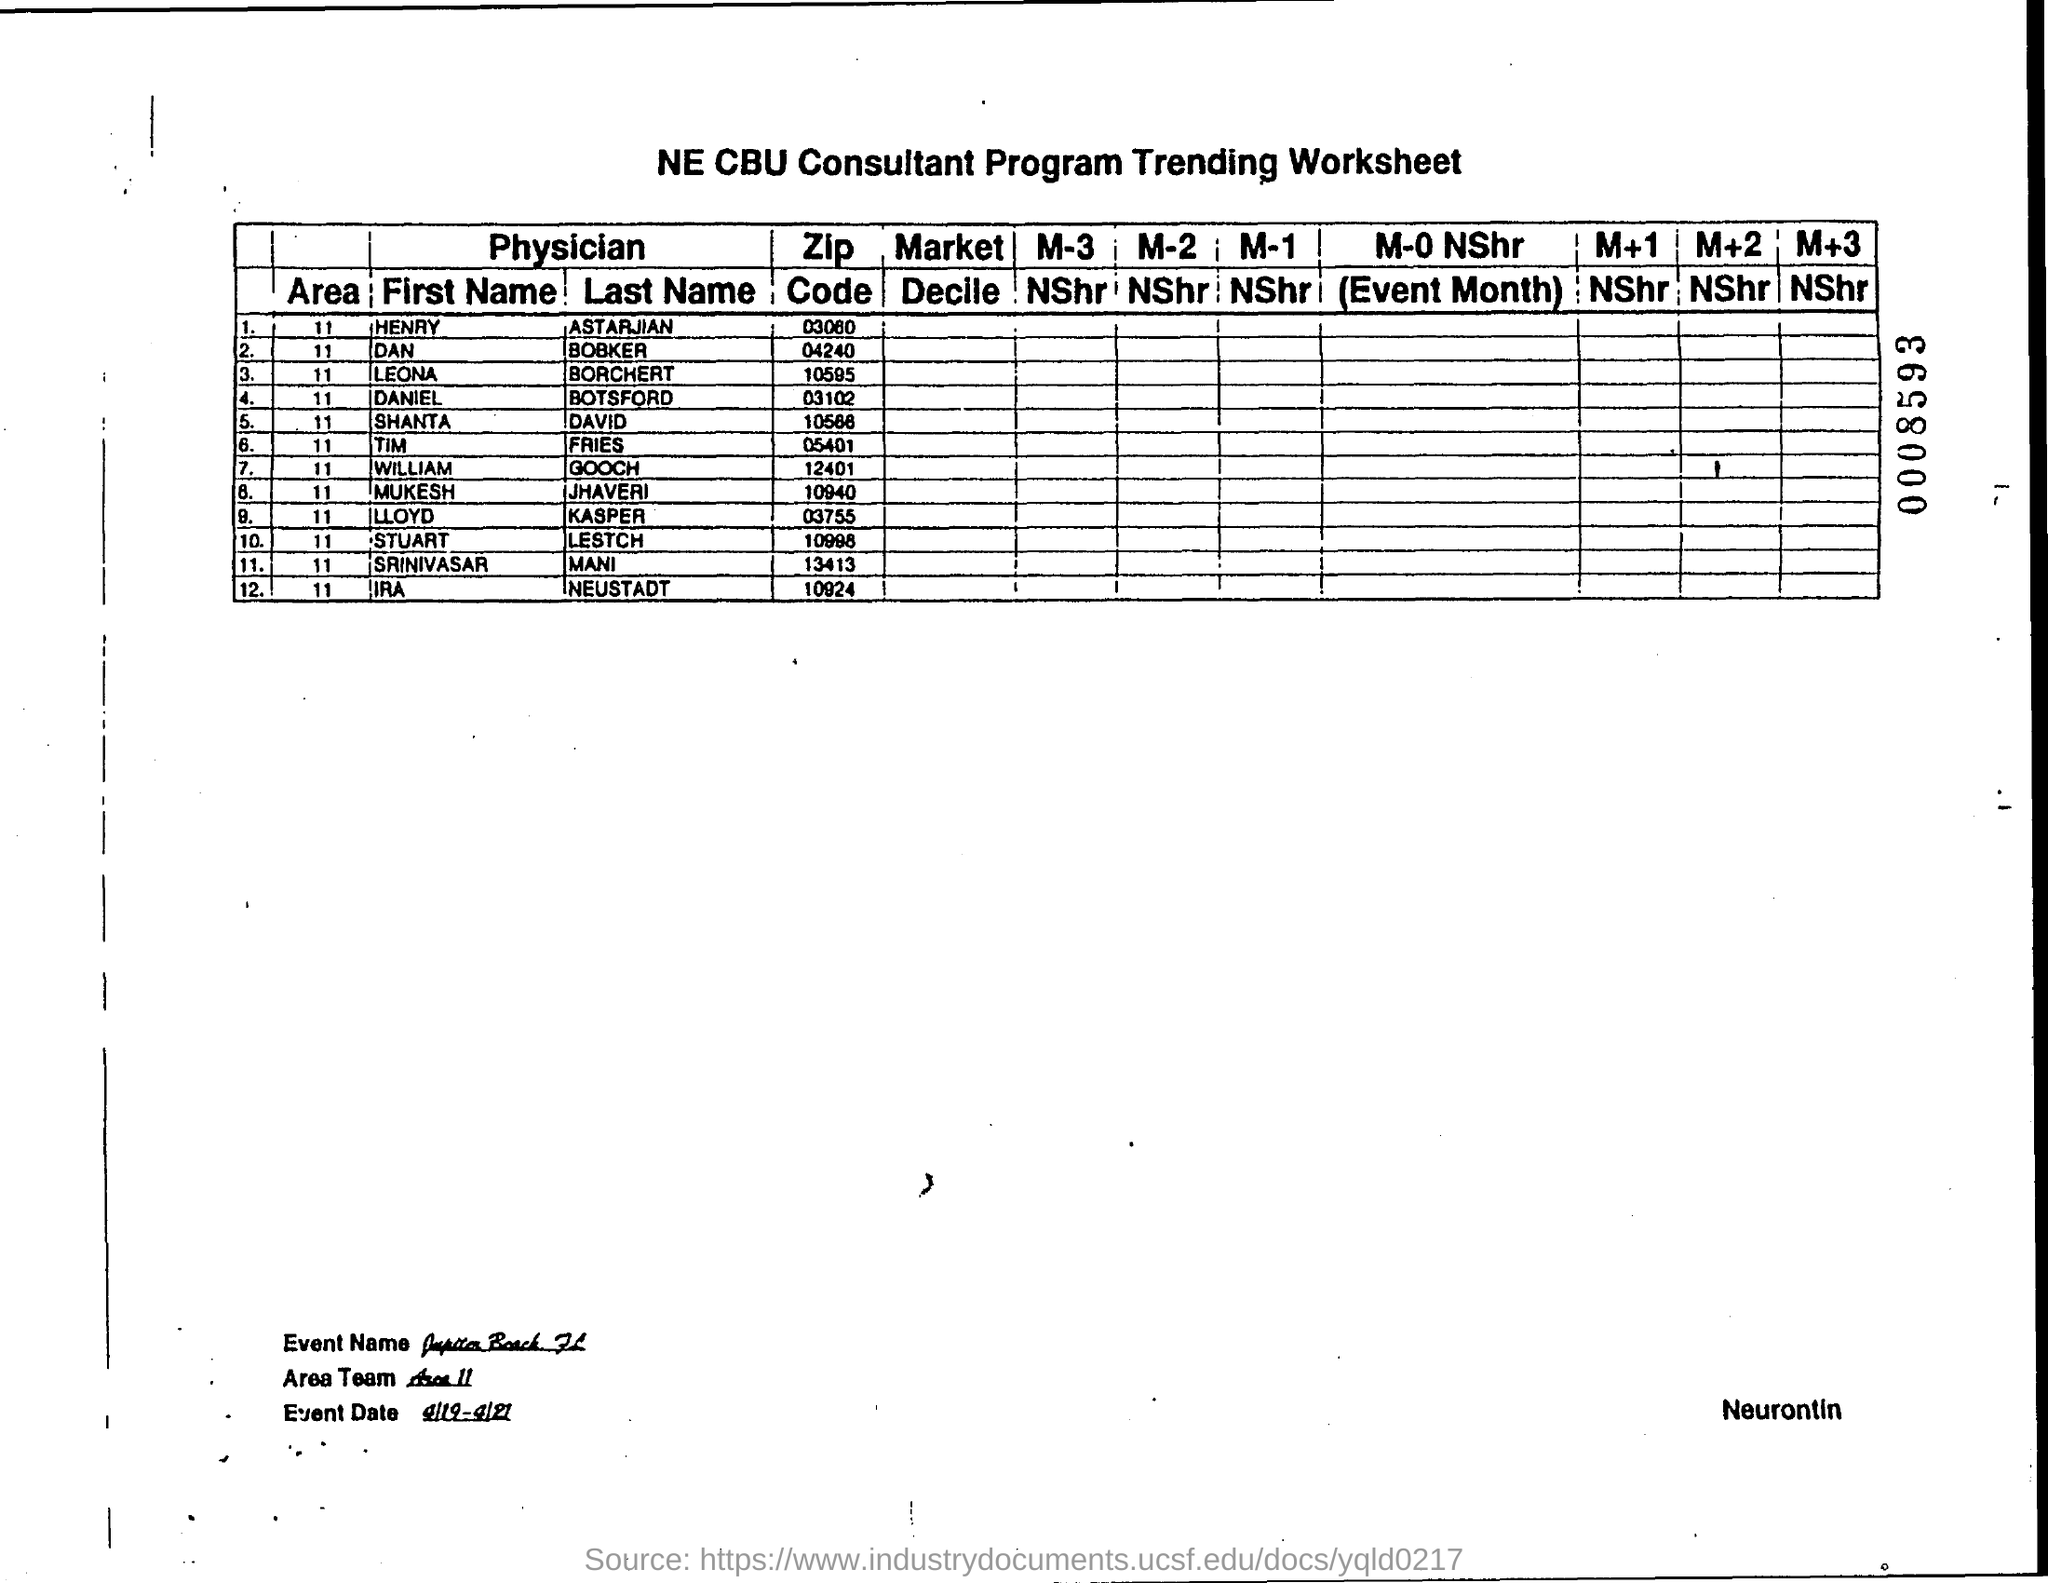What is the zipcode of henry astarjian ?
Keep it short and to the point. 03060. What is the zipcode of dan bobker ?
Provide a succinct answer. 04240. What is the zipcode of leona borchert ?
Your response must be concise. 10595. What is the zipcode of daniel botsford ?
Make the answer very short. 03102. What is the zipcode of tim fries ?
Provide a succinct answer. 05401. What is the zipcode of william gooch ?
Your answer should be very brief. 12401. What is the zipcode of mukesh jhaveri ?
Ensure brevity in your answer.  10940. What is the zipcode of lloyd kasper ?
Offer a terse response. 03755. What is the zipcode of stuart lestch ?
Give a very brief answer. 10998. 